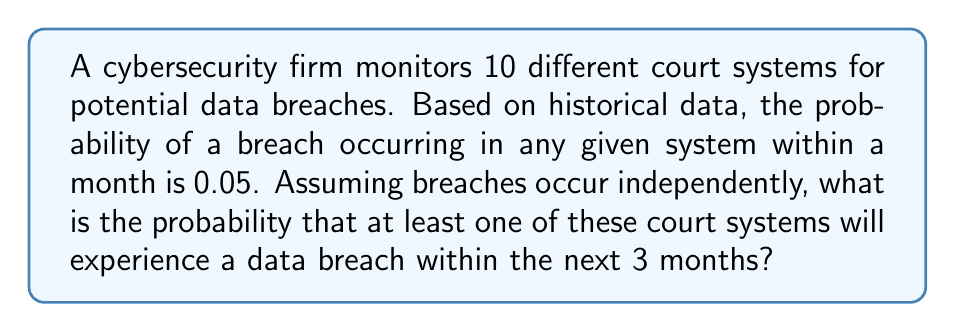Provide a solution to this math problem. Let's approach this step-by-step:

1) First, we need to calculate the probability of a breach occurring in a single system within 3 months:
   $P(\text{breach in 3 months}) = 1 - P(\text{no breach in 3 months})$
   $= 1 - (1 - 0.05)^3 = 1 - 0.95^3 = 1 - 0.857375 = 0.142625$

2) Now, we need to find the probability of at least one breach occurring in any of the 10 systems. It's easier to calculate the probability of no breaches occurring and then subtract from 1:

   $P(\text{at least one breach}) = 1 - P(\text{no breaches in any system})$

3) The probability of no breaches in any system is the product of the probabilities of no breaches in each system:

   $P(\text{no breaches in any system}) = (1 - 0.142625)^{10}$

4) Therefore, the probability of at least one breach is:

   $P(\text{at least one breach}) = 1 - (1 - 0.142625)^{10}$
   $= 1 - 0.857375^{10}$
   $= 1 - 0.2219$
   $= 0.7781$

5) Converting to a percentage:
   $0.7781 \times 100\% = 77.81\%$
Answer: 77.81% 